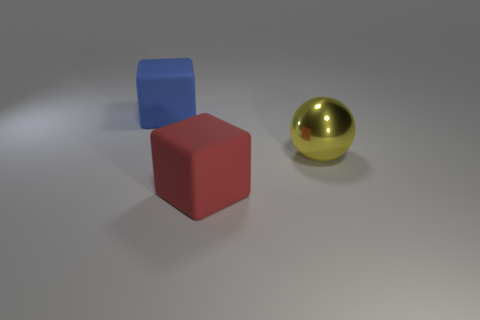Is there any other thing that is made of the same material as the yellow thing?
Provide a succinct answer. No. What material is the red block?
Your answer should be very brief. Rubber. Does the large cube left of the red matte block have the same material as the yellow sphere?
Your response must be concise. No. Is the number of big yellow objects that are left of the blue matte cube greater than the number of red matte blocks in front of the yellow metallic thing?
Offer a terse response. No. What size is the red block?
Offer a terse response. Large. There is a large object that is made of the same material as the big red block; what is its shape?
Your answer should be compact. Cube. Does the rubber object in front of the big shiny sphere have the same shape as the large metal thing?
Offer a very short reply. No. What number of objects are yellow matte cylinders or yellow things?
Offer a very short reply. 1. The object that is behind the red object and to the right of the big blue cube is made of what material?
Make the answer very short. Metal. Does the red block have the same size as the blue rubber cube?
Offer a very short reply. Yes. 